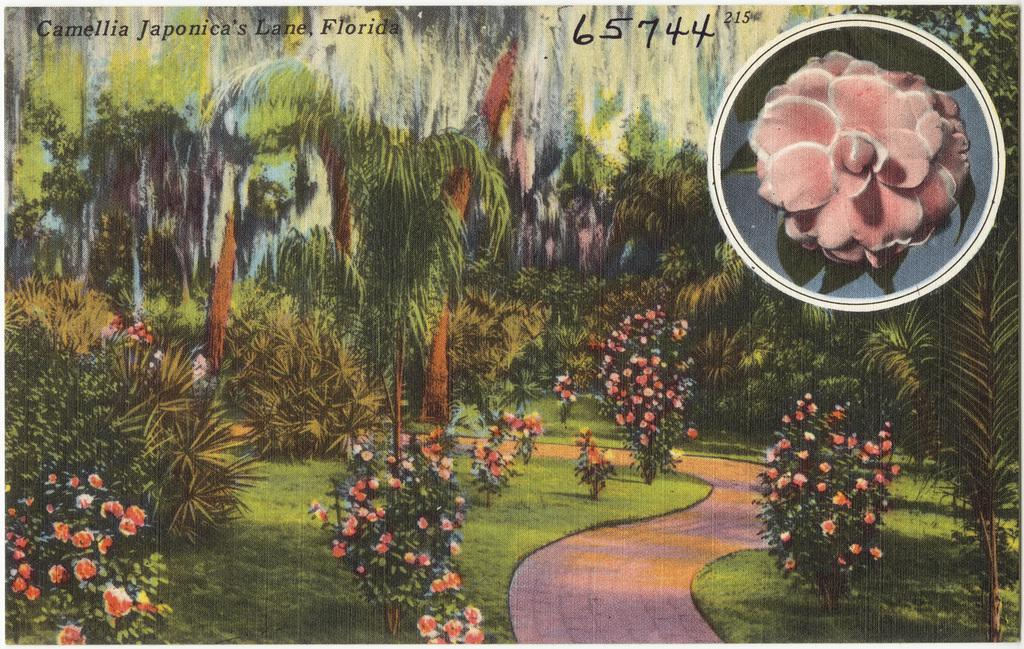What type of artwork is depicted in the image? The image is a painting. What natural elements can be seen in the painting? There are trees, plants, flowers, and grass visible in the painting. Is there any man-made structure in the painting? Yes, there is a walkway at the bottom of the painting. What is the mass of the tiger in the painting? There is no tiger present in the painting. 